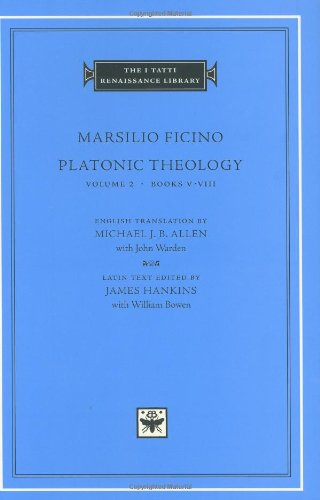What is the title of this book? The title of the book shown is 'Platonic Theology, Volume 2: Books V-VIII,' part of The I Tatti Renaissance Library series, which offers a scholarly exploration of Renaissance thought. 